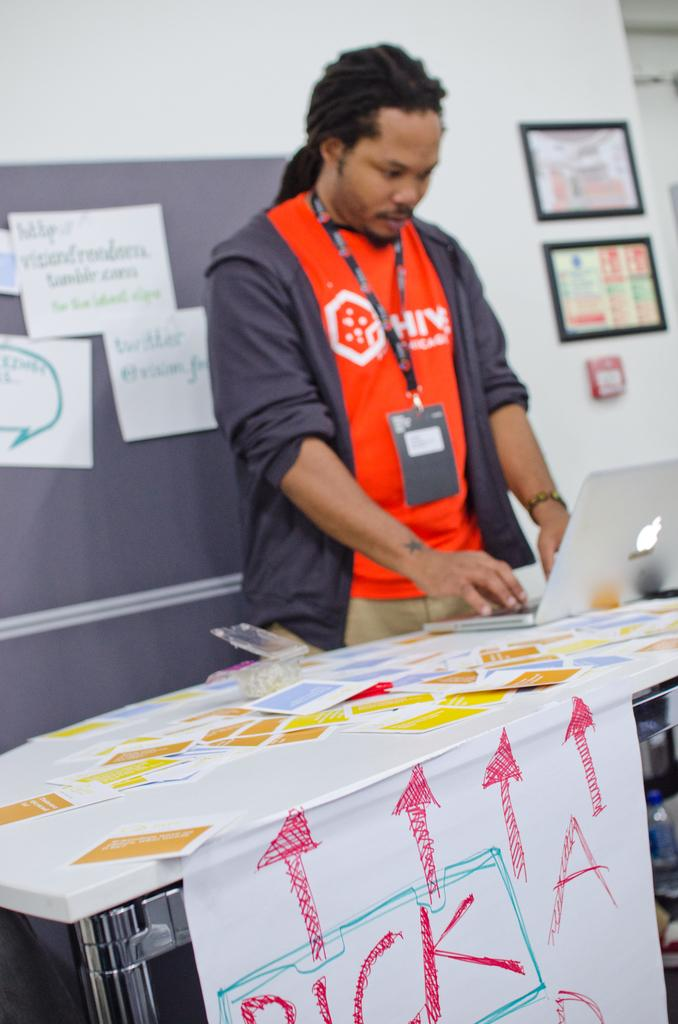What can be seen in the background of the image? There are photo frames and posters in the background of the image. What is located in the middle of the image? There is a table in the middle of the image. What is on the table in the image? There is a laptop on the table. Who or what is present in the middle of the image? There is a person in the middle of the image. What type of toys does the person have in their hand in the image? There are no toys present in the image; the person is not holding any. What is the person's opinion on the umbrella in the image? There is no umbrella present in the image, so it is not possible to determine the person's opinion on it. 